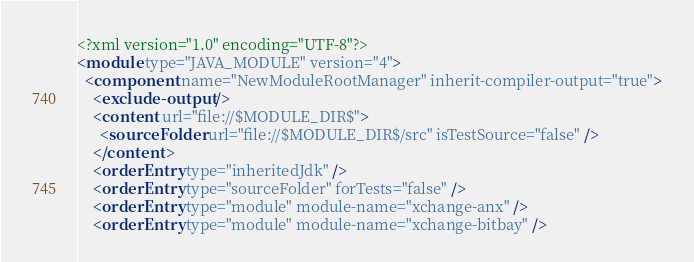Convert code to text. <code><loc_0><loc_0><loc_500><loc_500><_XML_><?xml version="1.0" encoding="UTF-8"?>
<module type="JAVA_MODULE" version="4">
  <component name="NewModuleRootManager" inherit-compiler-output="true">
    <exclude-output />
    <content url="file://$MODULE_DIR$">
      <sourceFolder url="file://$MODULE_DIR$/src" isTestSource="false" />
    </content>
    <orderEntry type="inheritedJdk" />
    <orderEntry type="sourceFolder" forTests="false" />
    <orderEntry type="module" module-name="xchange-anx" />
    <orderEntry type="module" module-name="xchange-bitbay" /></code> 